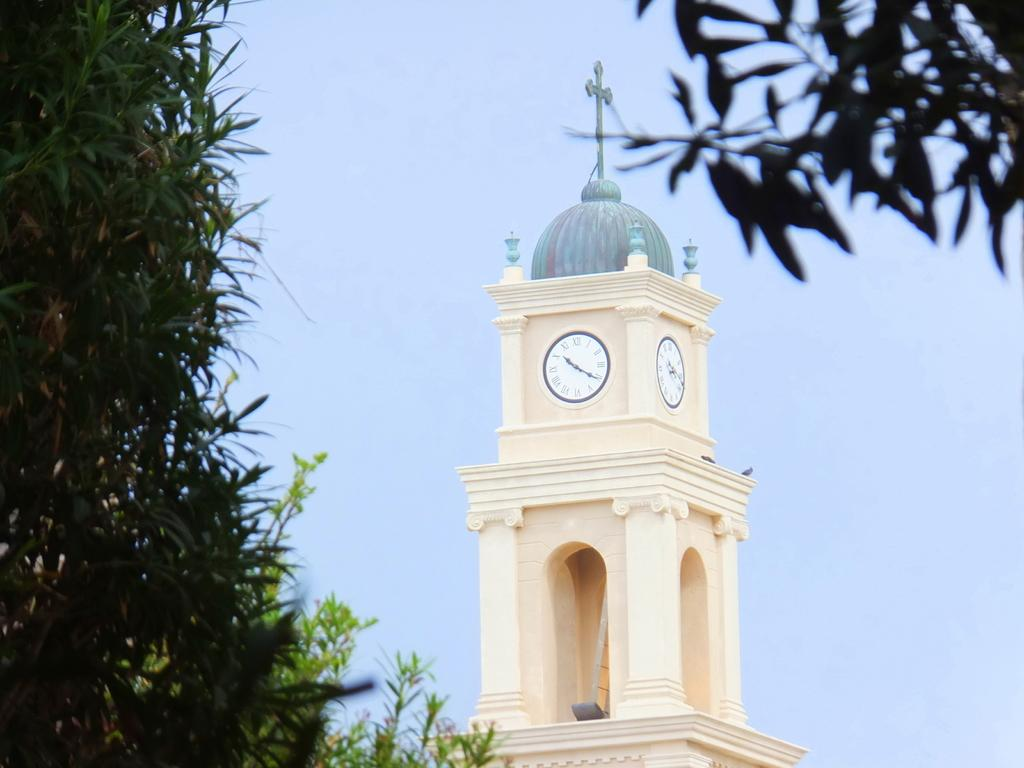What is the main structure in the center of the image? There is a clock tower in the center of the image. What can be seen in the background of the image? There are trees and the sky visible in the background of the image. How many books can be seen on the clock tower in the image? There are no books present on the clock tower in the image. 